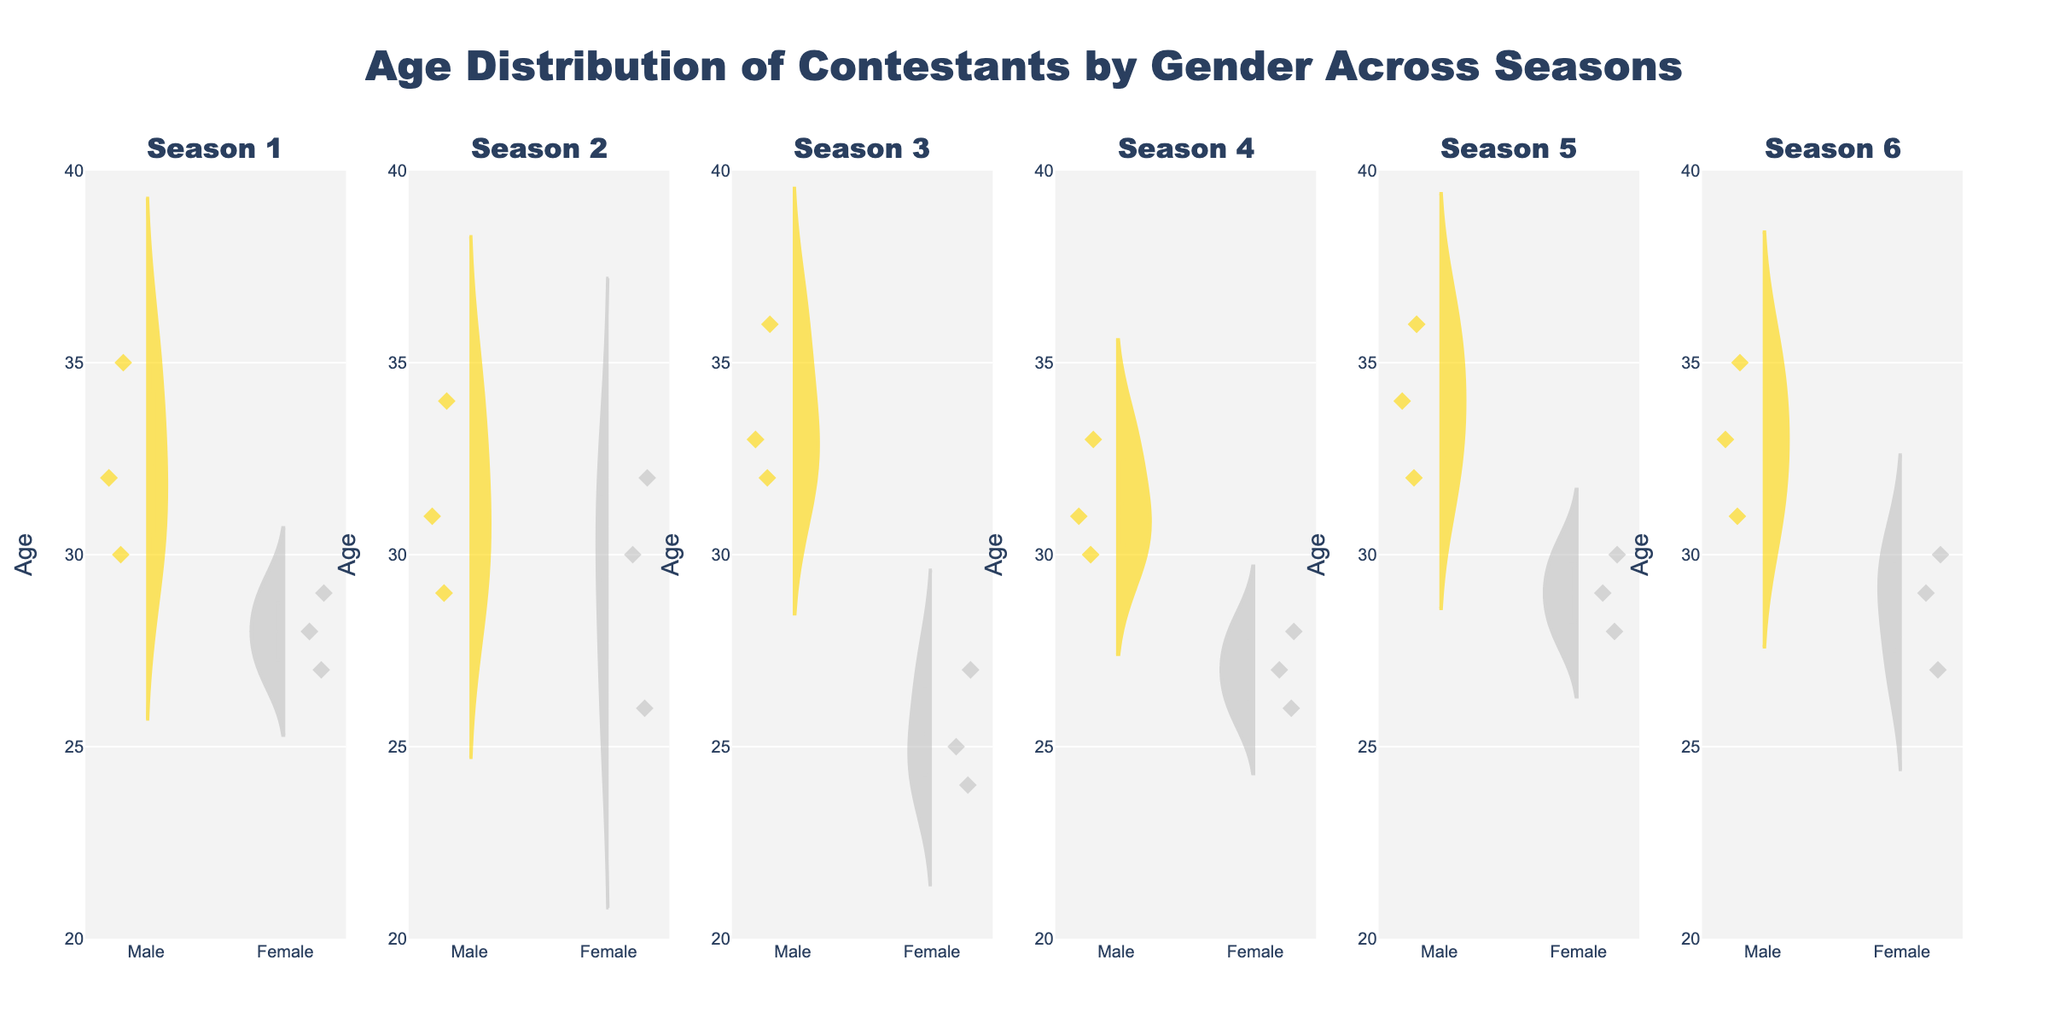What season shows the oldest male contestant? By looking at the violin charts, we can see that each subplot corresponds to a different season. Comparing the highest points for males, Season 5 has the oldest male contestant at age 36.
Answer: Season 5 Which gender has a lower median age in Season 2? In the violin chart for Season 2, the median age is indicated by the dashed line inside each violin. The female group has a lower median age compared to the males.
Answer: Female How many data points for male contestants are there in Season 4? By counting the number of individual points (diamonds) representing male contestants in the Season 4 subplot, we see there are three data points.
Answer: 3 What is the youngest age shown for female contestants across all seasons? Observing all female violin plots across the seasons, the lowest point is at age 24, seen in Season 3 and Season 4.
Answer: 24 Which season has the smallest age range for male contestants? The age range is the difference between the highest and lowest points of the male violin plots. Season 1 has the narrowest range, from approximately age 30 to 35, resulting in an age range of 5 years.
Answer: Season 1 In Season 6, which gender has the greater interquartile range (IQR)? The IQR is the range between the first and third quartiles. By observing the boxes within the violin plots, males have a wider box compared to females in Season 6, indicating a greater IQR.
Answer: Male Do female contestants have a consistently lower mean age than male contestants across the seasons? The mean is shown by the line across the width of the violin plots. By comparing these lines season by season, we observe that in all seasons except Season 1, females have a slightly lower mean age.
Answer: Yes, except Season 1 What is the median age of male contestants in Season 3? The median age is indicated by the dashed line inside the violin plot. For males in Season 3, the median age is 33.
Answer: 33 